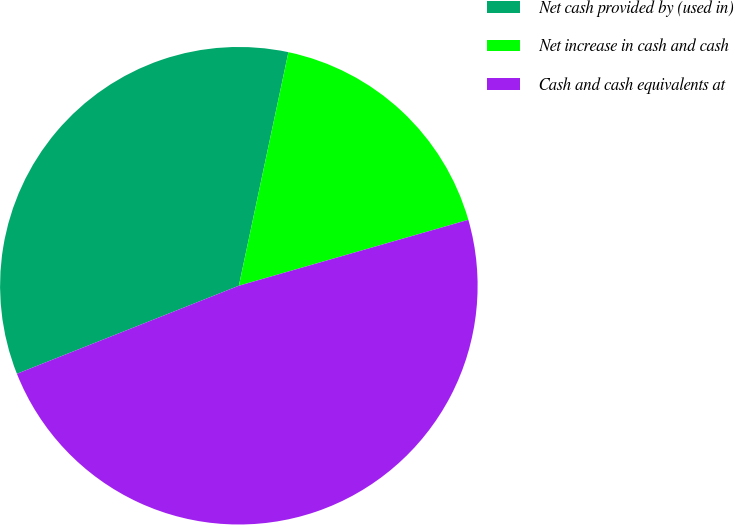Convert chart to OTSL. <chart><loc_0><loc_0><loc_500><loc_500><pie_chart><fcel>Net cash provided by (used in)<fcel>Net increase in cash and cash<fcel>Cash and cash equivalents at<nl><fcel>34.34%<fcel>17.22%<fcel>48.44%<nl></chart> 